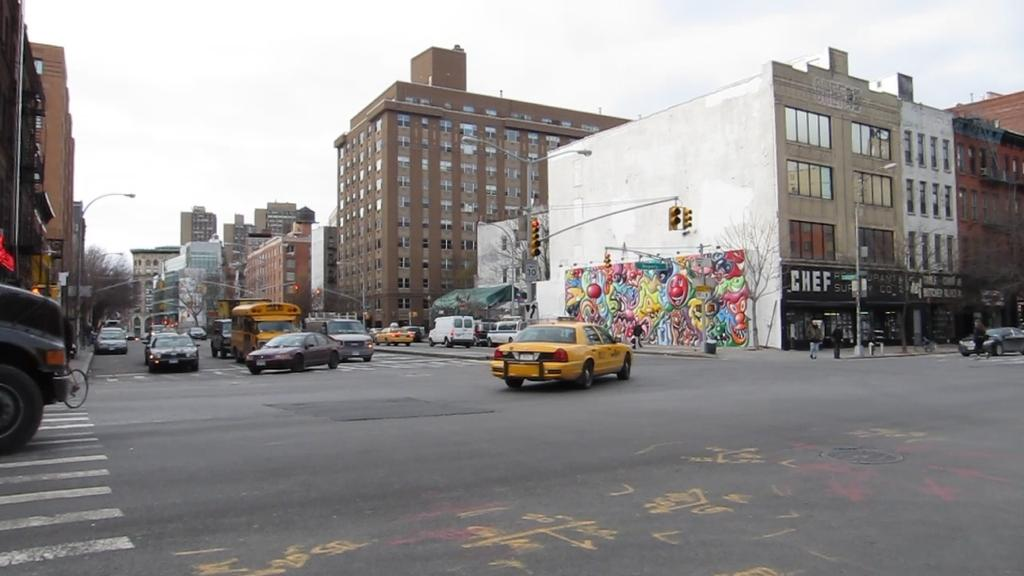Provide a one-sentence caption for the provided image. A yellow cab turns at an intersection, with a store with "chef" written on the sign. 